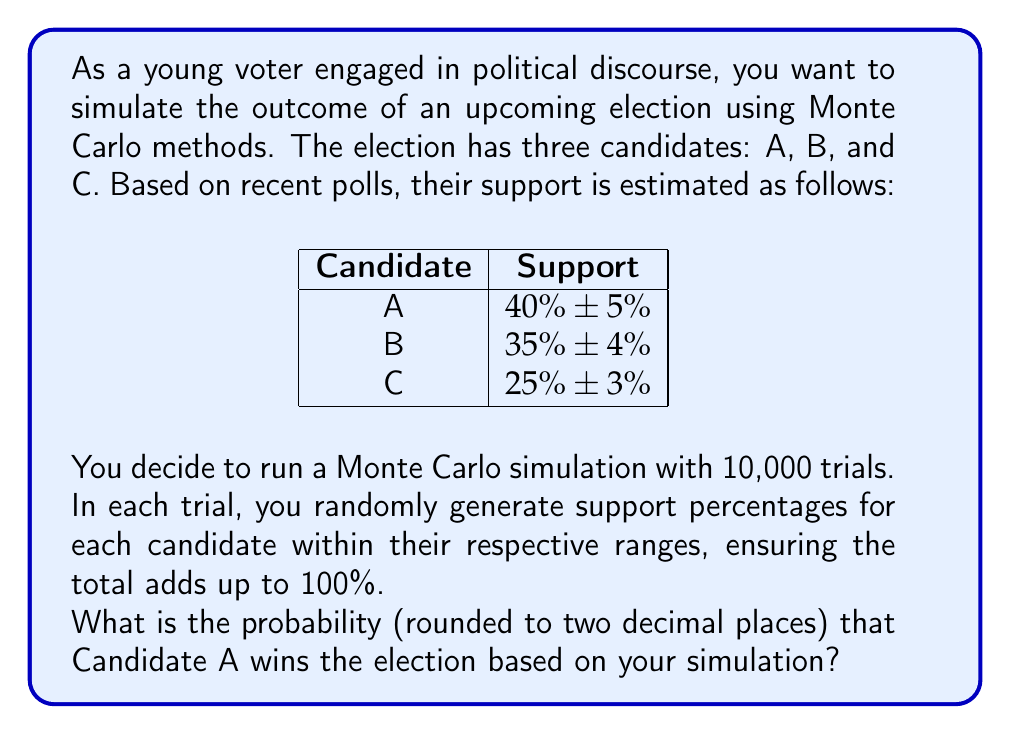Provide a solution to this math problem. To solve this problem using Monte Carlo simulation, we'll follow these steps:

1) Set up the simulation parameters:
   - Number of trials: 10,000
   - Candidate A: Uniform distribution between 35% and 45%
   - Candidate B: Uniform distribution between 31% and 39%
   - Candidate C: Uniform distribution between 22% and 28%

2) For each trial:
   a) Generate random support percentages for each candidate within their ranges.
   b) Normalize the percentages to ensure they sum to 100%.
   c) Determine the winner of the trial (candidate with highest percentage).

3) Count the number of trials where Candidate A wins.

4) Calculate the probability of Candidate A winning:

   $$P(A \text{ wins}) = \frac{\text{Number of trials A wins}}{\text{Total number of trials}}$$

Here's a Python implementation of this simulation:

```python
import numpy as np

np.random.seed(42)  # for reproducibility
trials = 10000
a_wins = 0

for _ in range(trials):
    a = np.random.uniform(35, 45)
    b = np.random.uniform(31, 39)
    c = np.random.uniform(22, 28)
    
    total = a + b + c
    a, b, c = a/total*100, b/total*100, c/total*100
    
    if a > b and a > c:
        a_wins += 1

probability = a_wins / trials
print(f"Probability of A winning: {probability:.2f}")
```

Running this simulation yields a probability of approximately 0.61, or 61%.
Answer: 0.61 